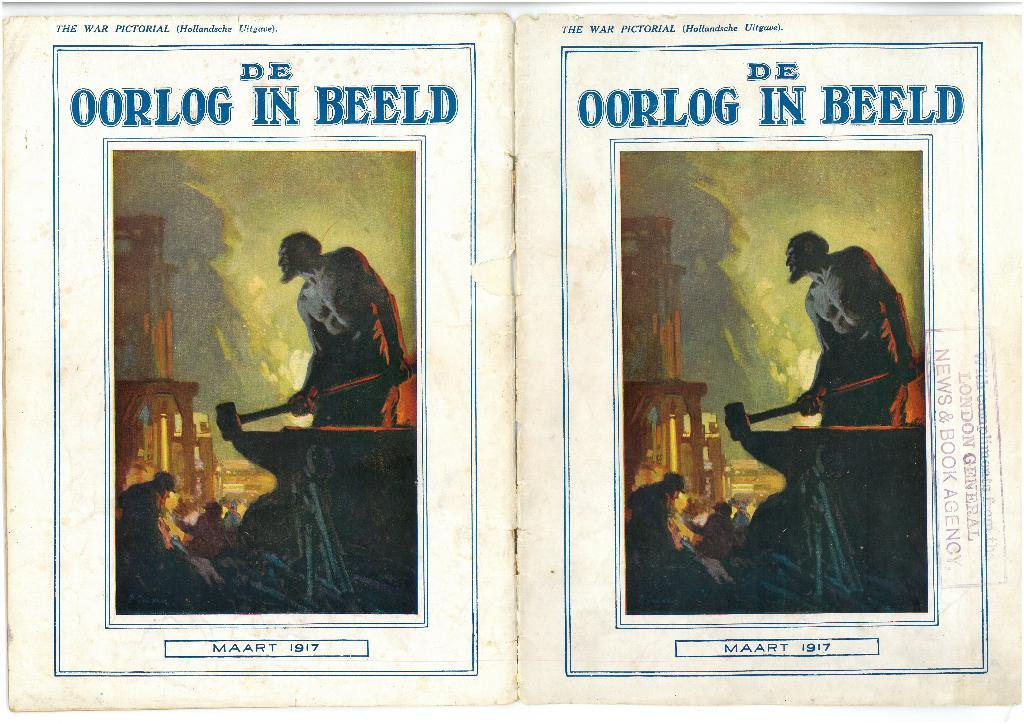Provide a one-sentence caption for the provided image. Two images that are a cover of a book that reads De Oorlog in Beeld. 